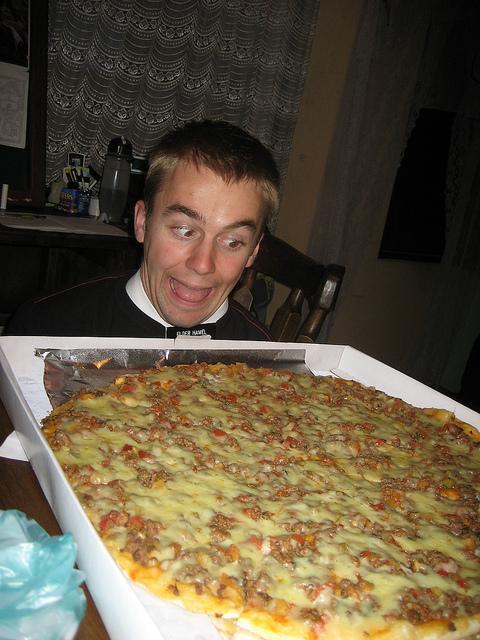How many pizzas are visible?
Give a very brief answer. 1. How many dining tables can you see?
Give a very brief answer. 2. How many bus on the road?
Give a very brief answer. 0. 